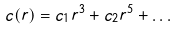<formula> <loc_0><loc_0><loc_500><loc_500>c ( r ) = c _ { 1 } r ^ { 3 } + c _ { 2 } r ^ { 5 } + \dots</formula> 